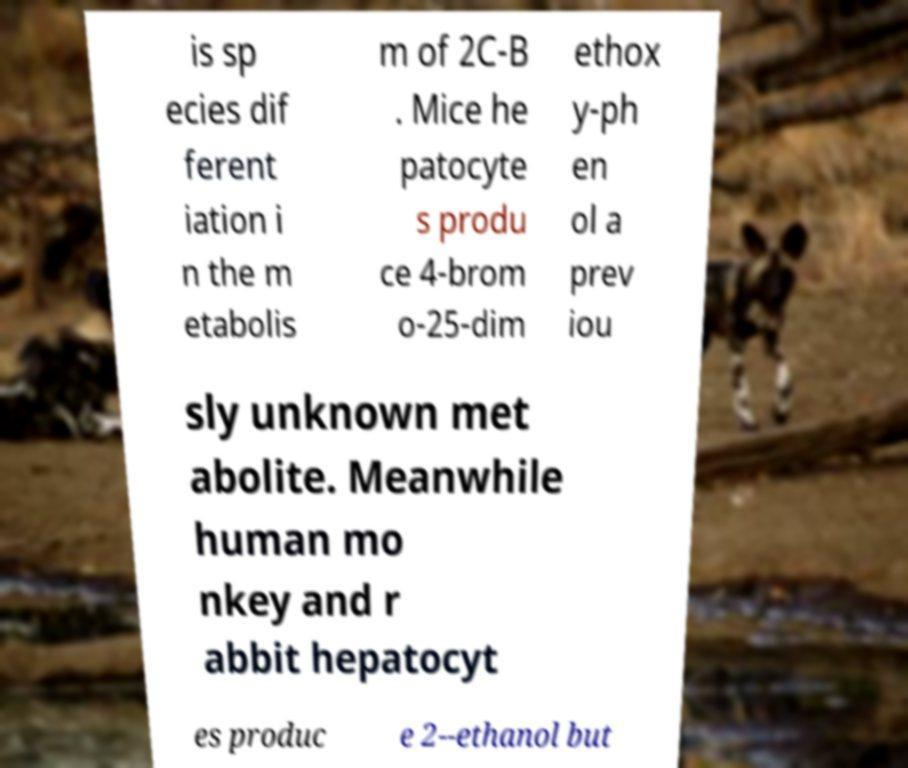Can you accurately transcribe the text from the provided image for me? is sp ecies dif ferent iation i n the m etabolis m of 2C-B . Mice he patocyte s produ ce 4-brom o-25-dim ethox y-ph en ol a prev iou sly unknown met abolite. Meanwhile human mo nkey and r abbit hepatocyt es produc e 2--ethanol but 